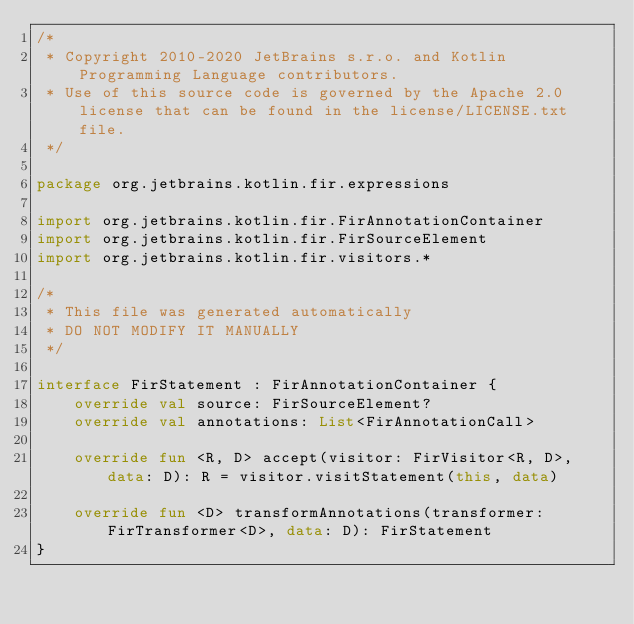Convert code to text. <code><loc_0><loc_0><loc_500><loc_500><_Kotlin_>/*
 * Copyright 2010-2020 JetBrains s.r.o. and Kotlin Programming Language contributors.
 * Use of this source code is governed by the Apache 2.0 license that can be found in the license/LICENSE.txt file.
 */

package org.jetbrains.kotlin.fir.expressions

import org.jetbrains.kotlin.fir.FirAnnotationContainer
import org.jetbrains.kotlin.fir.FirSourceElement
import org.jetbrains.kotlin.fir.visitors.*

/*
 * This file was generated automatically
 * DO NOT MODIFY IT MANUALLY
 */

interface FirStatement : FirAnnotationContainer {
    override val source: FirSourceElement?
    override val annotations: List<FirAnnotationCall>

    override fun <R, D> accept(visitor: FirVisitor<R, D>, data: D): R = visitor.visitStatement(this, data)

    override fun <D> transformAnnotations(transformer: FirTransformer<D>, data: D): FirStatement
}
</code> 